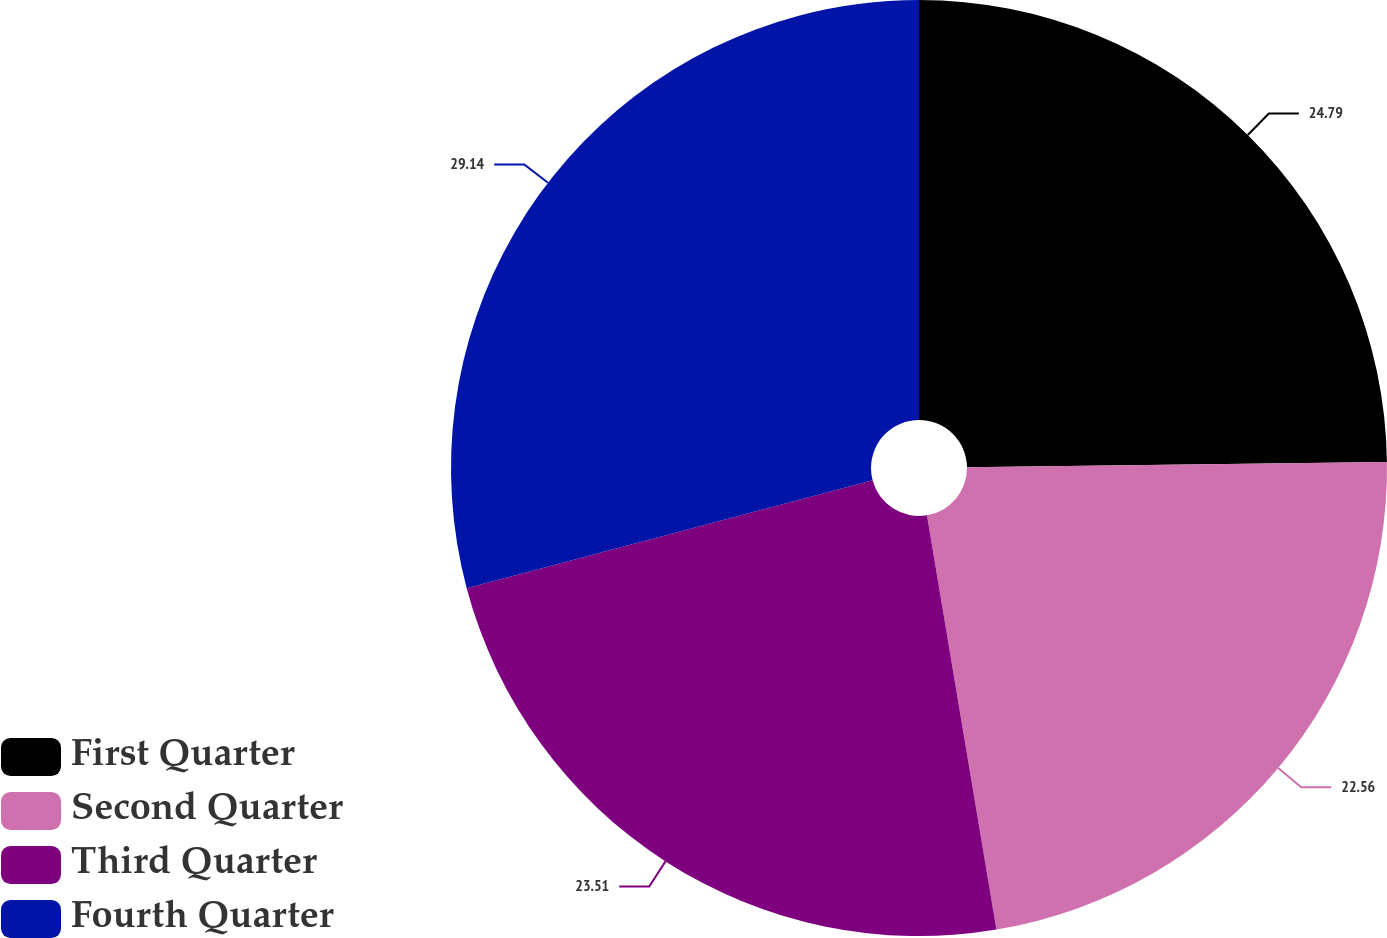Convert chart. <chart><loc_0><loc_0><loc_500><loc_500><pie_chart><fcel>First Quarter<fcel>Second Quarter<fcel>Third Quarter<fcel>Fourth Quarter<nl><fcel>24.79%<fcel>22.56%<fcel>23.51%<fcel>29.13%<nl></chart> 